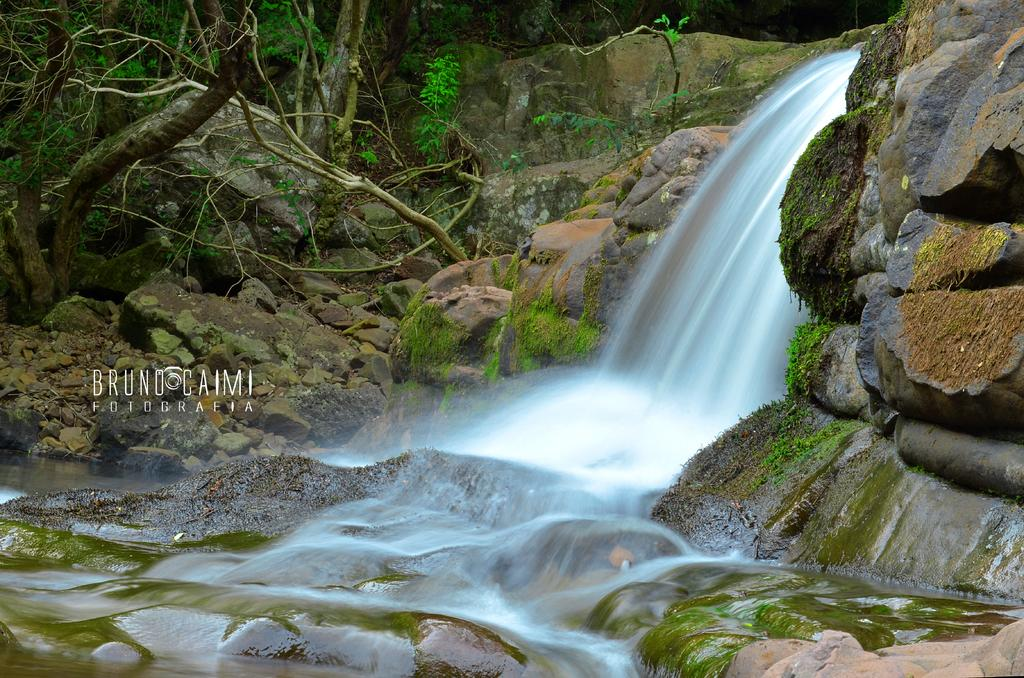What natural feature is the main subject of the image? There is a waterfall in the image. What type of geological formation can be seen in the image? Rocks are present in the image. What type of vegetation is visible in the image? Plants and trees are present in the image. Can you describe any additional features on the image? There is a watermark on the left side of the image. What type of fog can be seen surrounding the waterfall in the image? There is no fog present in the image; it is a clear view of the waterfall. What type of lumber is being harvested from the trees in the image? There is no lumber harvesting depicted in the image; it only shows trees and a waterfall. 